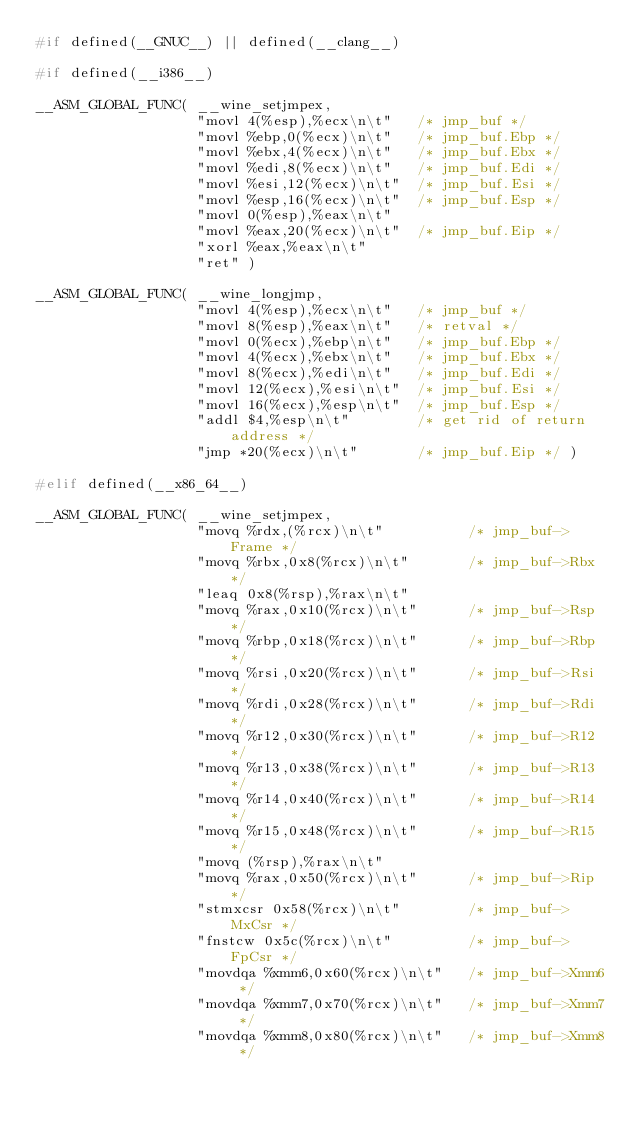Convert code to text. <code><loc_0><loc_0><loc_500><loc_500><_C_>#if defined(__GNUC__) || defined(__clang__)

#if defined(__i386__)

__ASM_GLOBAL_FUNC( __wine_setjmpex,
                   "movl 4(%esp),%ecx\n\t"   /* jmp_buf */
                   "movl %ebp,0(%ecx)\n\t"   /* jmp_buf.Ebp */
                   "movl %ebx,4(%ecx)\n\t"   /* jmp_buf.Ebx */
                   "movl %edi,8(%ecx)\n\t"   /* jmp_buf.Edi */
                   "movl %esi,12(%ecx)\n\t"  /* jmp_buf.Esi */
                   "movl %esp,16(%ecx)\n\t"  /* jmp_buf.Esp */
                   "movl 0(%esp),%eax\n\t"
                   "movl %eax,20(%ecx)\n\t"  /* jmp_buf.Eip */
                   "xorl %eax,%eax\n\t"
                   "ret" )

__ASM_GLOBAL_FUNC( __wine_longjmp,
                   "movl 4(%esp),%ecx\n\t"   /* jmp_buf */
                   "movl 8(%esp),%eax\n\t"   /* retval */
                   "movl 0(%ecx),%ebp\n\t"   /* jmp_buf.Ebp */
                   "movl 4(%ecx),%ebx\n\t"   /* jmp_buf.Ebx */
                   "movl 8(%ecx),%edi\n\t"   /* jmp_buf.Edi */
                   "movl 12(%ecx),%esi\n\t"  /* jmp_buf.Esi */
                   "movl 16(%ecx),%esp\n\t"  /* jmp_buf.Esp */
                   "addl $4,%esp\n\t"        /* get rid of return address */
                   "jmp *20(%ecx)\n\t"       /* jmp_buf.Eip */ )

#elif defined(__x86_64__)

__ASM_GLOBAL_FUNC( __wine_setjmpex,
                   "movq %rdx,(%rcx)\n\t"          /* jmp_buf->Frame */
                   "movq %rbx,0x8(%rcx)\n\t"       /* jmp_buf->Rbx */
                   "leaq 0x8(%rsp),%rax\n\t"
                   "movq %rax,0x10(%rcx)\n\t"      /* jmp_buf->Rsp */
                   "movq %rbp,0x18(%rcx)\n\t"      /* jmp_buf->Rbp */
                   "movq %rsi,0x20(%rcx)\n\t"      /* jmp_buf->Rsi */
                   "movq %rdi,0x28(%rcx)\n\t"      /* jmp_buf->Rdi */
                   "movq %r12,0x30(%rcx)\n\t"      /* jmp_buf->R12 */
                   "movq %r13,0x38(%rcx)\n\t"      /* jmp_buf->R13 */
                   "movq %r14,0x40(%rcx)\n\t"      /* jmp_buf->R14 */
                   "movq %r15,0x48(%rcx)\n\t"      /* jmp_buf->R15 */
                   "movq (%rsp),%rax\n\t"
                   "movq %rax,0x50(%rcx)\n\t"      /* jmp_buf->Rip */
                   "stmxcsr 0x58(%rcx)\n\t"        /* jmp_buf->MxCsr */
                   "fnstcw 0x5c(%rcx)\n\t"         /* jmp_buf->FpCsr */
                   "movdqa %xmm6,0x60(%rcx)\n\t"   /* jmp_buf->Xmm6 */
                   "movdqa %xmm7,0x70(%rcx)\n\t"   /* jmp_buf->Xmm7 */
                   "movdqa %xmm8,0x80(%rcx)\n\t"   /* jmp_buf->Xmm8 */</code> 